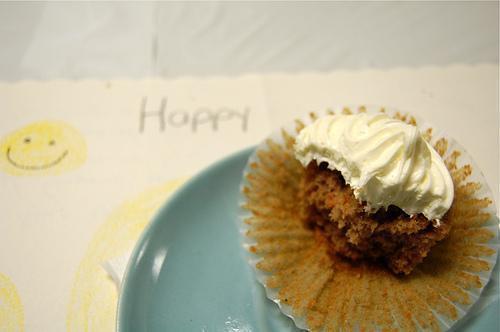How many bytes are left in the cupcake?
Give a very brief answer. 2. 